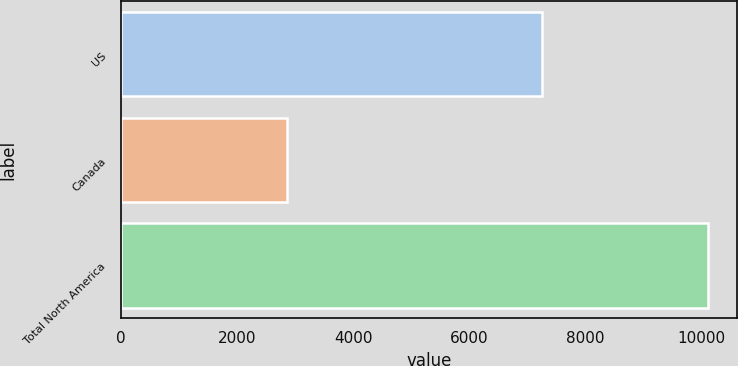Convert chart to OTSL. <chart><loc_0><loc_0><loc_500><loc_500><bar_chart><fcel>US<fcel>Canada<fcel>Total North America<nl><fcel>7252<fcel>2852<fcel>10104<nl></chart> 